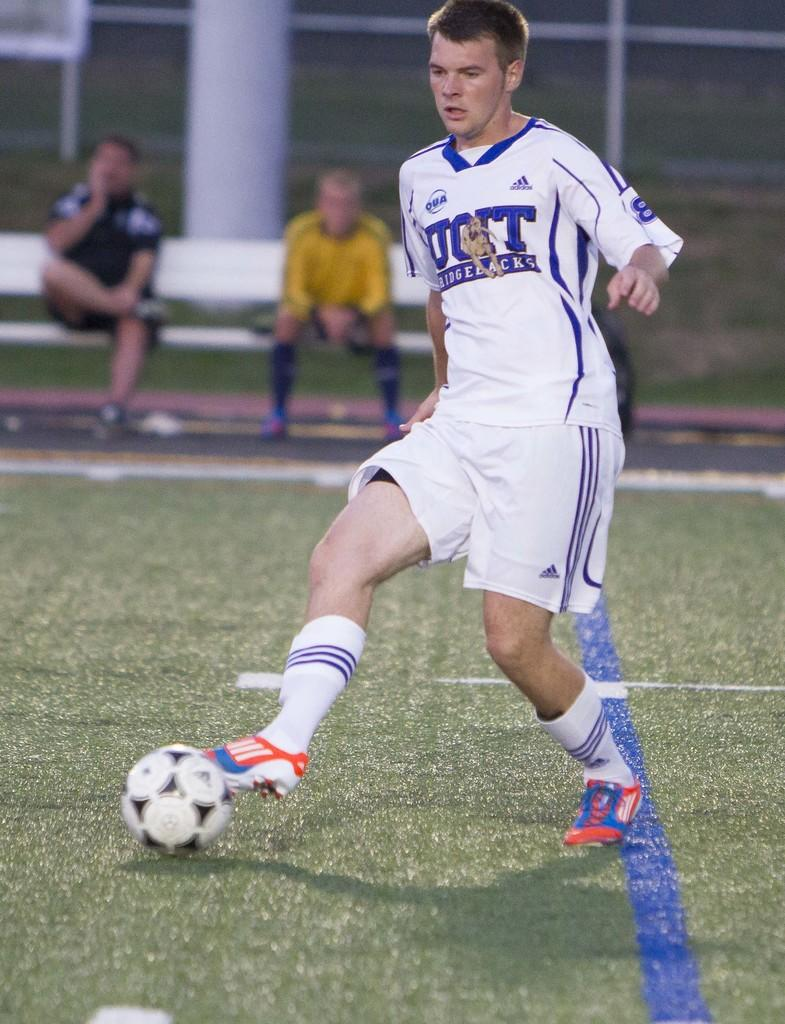<image>
Offer a succinct explanation of the picture presented. The Ridgebacks player does some footwork in front of two bored looking players on the bench. 